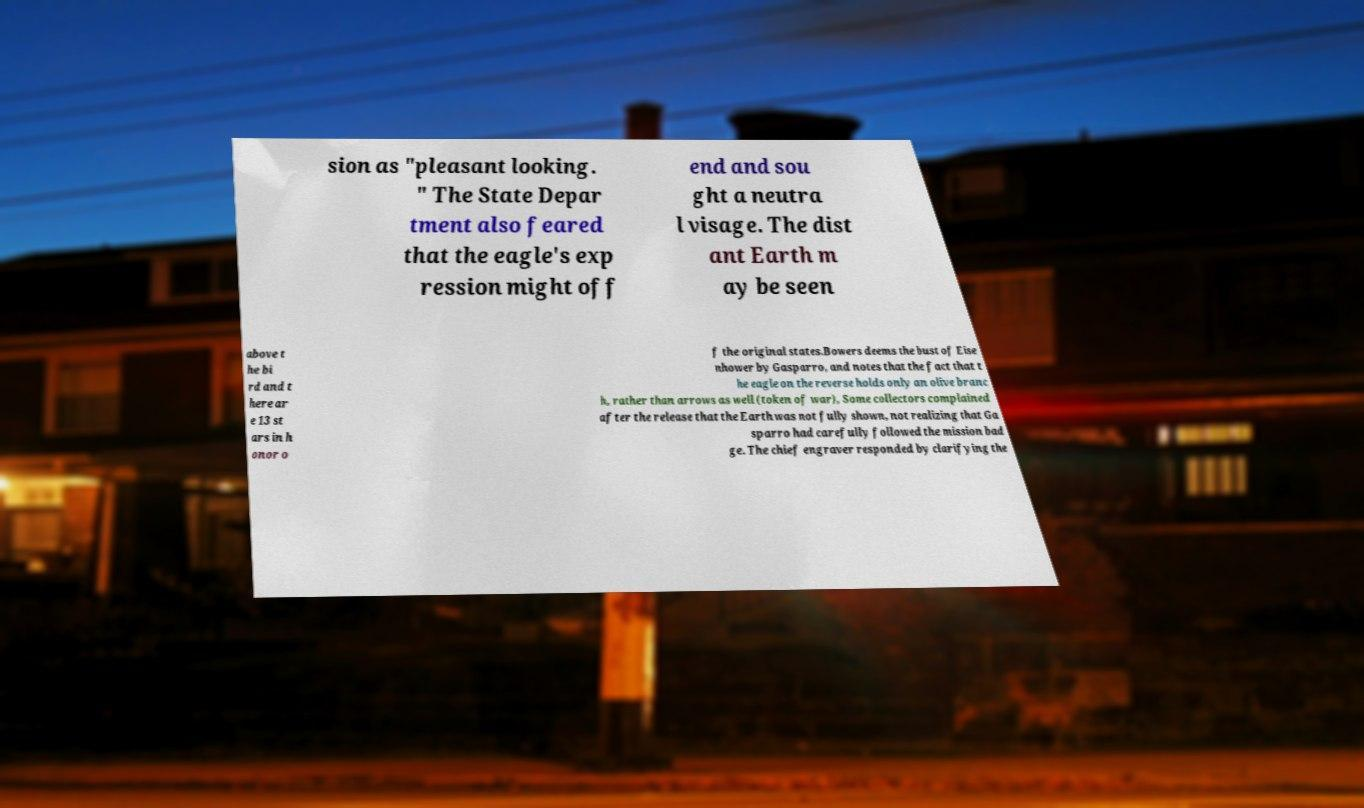Can you accurately transcribe the text from the provided image for me? sion as "pleasant looking. " The State Depar tment also feared that the eagle's exp ression might off end and sou ght a neutra l visage. The dist ant Earth m ay be seen above t he bi rd and t here ar e 13 st ars in h onor o f the original states.Bowers deems the bust of Eise nhower by Gasparro, and notes that the fact that t he eagle on the reverse holds only an olive branc h, rather than arrows as well (token of war), Some collectors complained after the release that the Earth was not fully shown, not realizing that Ga sparro had carefully followed the mission bad ge. The chief engraver responded by clarifying the 